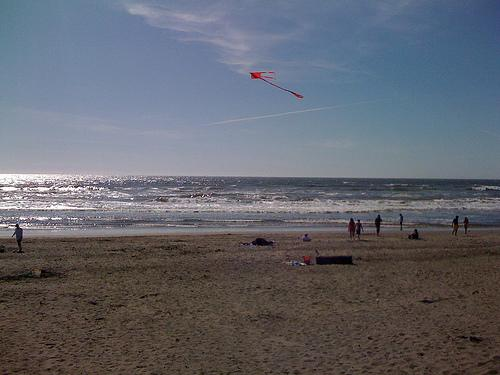Provide a brief overview of the scene depicted in the image. People are enjoying a sunny day on the beach with a red kite flying in the clear blue sky and foamy ocean waves nearby. In a single sentence, summarize the main attraction on this beach scene. A red kite with three tails catches attention as it soars high in the sky above the people on the beach. Briefly explain the condition of the ocean and the sand in the image. The ocean is blue and white with breaking waves and ripples, while the brown sand is covered with numerous footprints. Describe the kite's appearance and how it is positioned in the sky. The red kite, with an orange shade, is soaring in the sky with its long tails flowing gracefully, complementing the picturesque beach scene. Mention the dominant color and elements present in the sky. The sky is mostly blue and sunny, with thin clouds high in the sky and a jet trail visible among them. Give an emotional response to the image as if you were there. I feel relaxed and happy seeing people enjoying themselves on the beach, with the red kite flying high in the clear blue sky above the ocean waves. What is the most striking feature in the image, and what is its significance? The most striking feature is the red kite flying in the sky, symbolizing leisure and freedom that people experience at the beach. Describe the appearance and activities of the people in the image. Several people are standing, and one person is laying down on the beach, while everyone is enjoying the ocean and sand under clear blue skies. Use a metaphor or simile to describe the image. The beach scene is like a canvas painted with people, a red kite, and ocean waves under a vast sky, making it a masterpiece of nature. Identify the number of people on the beach and their relationship with the ocean. There are seven people on the beach, standing or laying near the ocean and enjoying the beach's atmosphere. 